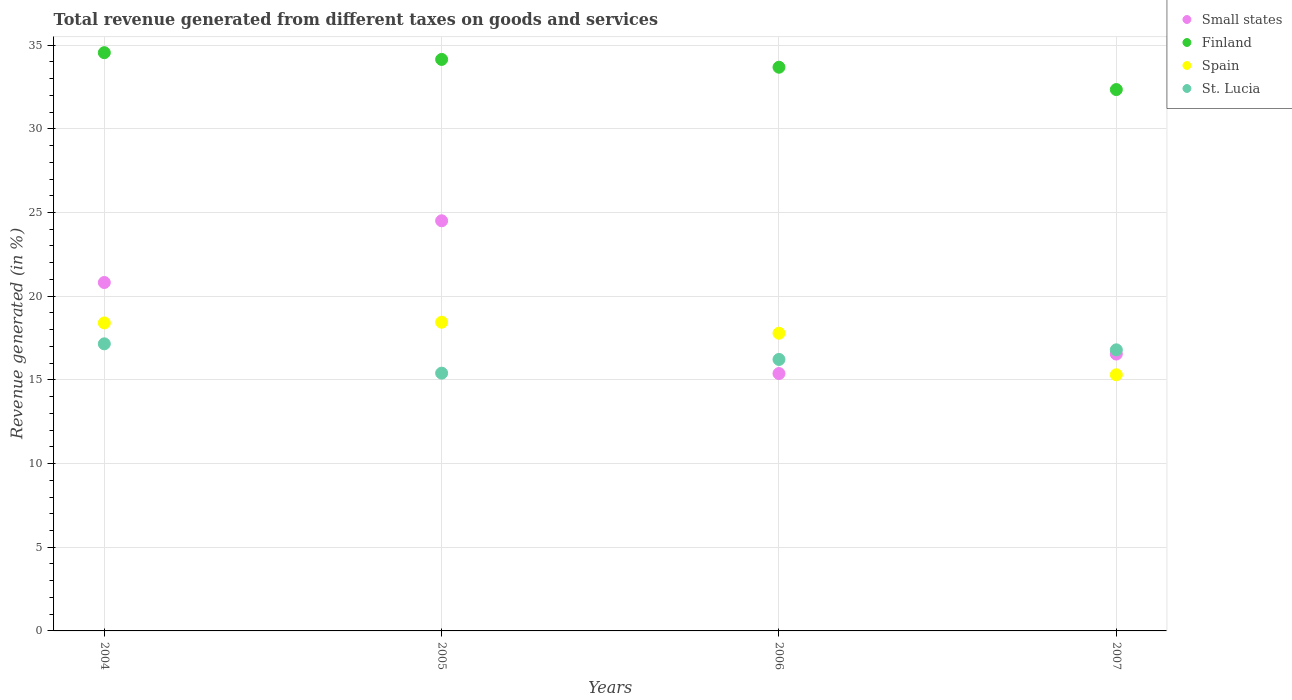What is the total revenue generated in St. Lucia in 2007?
Your answer should be compact. 16.8. Across all years, what is the maximum total revenue generated in Small states?
Provide a succinct answer. 24.51. Across all years, what is the minimum total revenue generated in St. Lucia?
Make the answer very short. 15.4. In which year was the total revenue generated in Finland maximum?
Ensure brevity in your answer.  2004. In which year was the total revenue generated in Finland minimum?
Keep it short and to the point. 2007. What is the total total revenue generated in Spain in the graph?
Provide a succinct answer. 69.94. What is the difference between the total revenue generated in Finland in 2004 and that in 2006?
Your answer should be very brief. 0.87. What is the difference between the total revenue generated in Finland in 2004 and the total revenue generated in Small states in 2005?
Offer a very short reply. 10.05. What is the average total revenue generated in Spain per year?
Provide a short and direct response. 17.49. In the year 2006, what is the difference between the total revenue generated in Finland and total revenue generated in St. Lucia?
Give a very brief answer. 17.46. In how many years, is the total revenue generated in Small states greater than 4 %?
Give a very brief answer. 4. What is the ratio of the total revenue generated in Finland in 2004 to that in 2006?
Ensure brevity in your answer.  1.03. Is the total revenue generated in St. Lucia in 2006 less than that in 2007?
Offer a very short reply. Yes. What is the difference between the highest and the second highest total revenue generated in Spain?
Offer a very short reply. 0.04. What is the difference between the highest and the lowest total revenue generated in Finland?
Your answer should be compact. 2.2. In how many years, is the total revenue generated in St. Lucia greater than the average total revenue generated in St. Lucia taken over all years?
Provide a short and direct response. 2. Is the sum of the total revenue generated in Finland in 2004 and 2006 greater than the maximum total revenue generated in St. Lucia across all years?
Your answer should be compact. Yes. Is it the case that in every year, the sum of the total revenue generated in Finland and total revenue generated in Small states  is greater than the sum of total revenue generated in St. Lucia and total revenue generated in Spain?
Offer a terse response. Yes. Is it the case that in every year, the sum of the total revenue generated in Small states and total revenue generated in Spain  is greater than the total revenue generated in St. Lucia?
Your answer should be very brief. Yes. Does the total revenue generated in St. Lucia monotonically increase over the years?
Keep it short and to the point. No. Is the total revenue generated in Spain strictly less than the total revenue generated in Small states over the years?
Provide a succinct answer. No. How many years are there in the graph?
Ensure brevity in your answer.  4. What is the difference between two consecutive major ticks on the Y-axis?
Offer a very short reply. 5. What is the title of the graph?
Make the answer very short. Total revenue generated from different taxes on goods and services. Does "Guinea" appear as one of the legend labels in the graph?
Provide a short and direct response. No. What is the label or title of the Y-axis?
Ensure brevity in your answer.  Revenue generated (in %). What is the Revenue generated (in %) in Small states in 2004?
Offer a very short reply. 20.82. What is the Revenue generated (in %) in Finland in 2004?
Provide a short and direct response. 34.55. What is the Revenue generated (in %) of Spain in 2004?
Provide a succinct answer. 18.4. What is the Revenue generated (in %) of St. Lucia in 2004?
Your answer should be very brief. 17.15. What is the Revenue generated (in %) of Small states in 2005?
Ensure brevity in your answer.  24.51. What is the Revenue generated (in %) in Finland in 2005?
Ensure brevity in your answer.  34.15. What is the Revenue generated (in %) of Spain in 2005?
Your answer should be compact. 18.45. What is the Revenue generated (in %) in St. Lucia in 2005?
Your response must be concise. 15.4. What is the Revenue generated (in %) in Small states in 2006?
Keep it short and to the point. 15.38. What is the Revenue generated (in %) in Finland in 2006?
Your response must be concise. 33.68. What is the Revenue generated (in %) in Spain in 2006?
Offer a very short reply. 17.79. What is the Revenue generated (in %) of St. Lucia in 2006?
Offer a very short reply. 16.22. What is the Revenue generated (in %) of Small states in 2007?
Provide a short and direct response. 16.54. What is the Revenue generated (in %) in Finland in 2007?
Make the answer very short. 32.35. What is the Revenue generated (in %) of Spain in 2007?
Provide a short and direct response. 15.31. What is the Revenue generated (in %) of St. Lucia in 2007?
Provide a short and direct response. 16.8. Across all years, what is the maximum Revenue generated (in %) of Small states?
Ensure brevity in your answer.  24.51. Across all years, what is the maximum Revenue generated (in %) of Finland?
Make the answer very short. 34.55. Across all years, what is the maximum Revenue generated (in %) of Spain?
Ensure brevity in your answer.  18.45. Across all years, what is the maximum Revenue generated (in %) in St. Lucia?
Your answer should be very brief. 17.15. Across all years, what is the minimum Revenue generated (in %) in Small states?
Give a very brief answer. 15.38. Across all years, what is the minimum Revenue generated (in %) in Finland?
Offer a terse response. 32.35. Across all years, what is the minimum Revenue generated (in %) of Spain?
Give a very brief answer. 15.31. Across all years, what is the minimum Revenue generated (in %) in St. Lucia?
Your answer should be compact. 15.4. What is the total Revenue generated (in %) of Small states in the graph?
Provide a short and direct response. 77.25. What is the total Revenue generated (in %) of Finland in the graph?
Ensure brevity in your answer.  134.73. What is the total Revenue generated (in %) of Spain in the graph?
Provide a succinct answer. 69.94. What is the total Revenue generated (in %) in St. Lucia in the graph?
Make the answer very short. 65.57. What is the difference between the Revenue generated (in %) in Small states in 2004 and that in 2005?
Offer a terse response. -3.69. What is the difference between the Revenue generated (in %) of Finland in 2004 and that in 2005?
Your response must be concise. 0.4. What is the difference between the Revenue generated (in %) in Spain in 2004 and that in 2005?
Ensure brevity in your answer.  -0.04. What is the difference between the Revenue generated (in %) of St. Lucia in 2004 and that in 2005?
Give a very brief answer. 1.75. What is the difference between the Revenue generated (in %) of Small states in 2004 and that in 2006?
Keep it short and to the point. 5.44. What is the difference between the Revenue generated (in %) in Finland in 2004 and that in 2006?
Your answer should be compact. 0.87. What is the difference between the Revenue generated (in %) of Spain in 2004 and that in 2006?
Provide a succinct answer. 0.62. What is the difference between the Revenue generated (in %) in St. Lucia in 2004 and that in 2006?
Your answer should be very brief. 0.93. What is the difference between the Revenue generated (in %) in Small states in 2004 and that in 2007?
Your response must be concise. 4.28. What is the difference between the Revenue generated (in %) of Finland in 2004 and that in 2007?
Provide a short and direct response. 2.2. What is the difference between the Revenue generated (in %) of Spain in 2004 and that in 2007?
Offer a very short reply. 3.1. What is the difference between the Revenue generated (in %) of St. Lucia in 2004 and that in 2007?
Your answer should be compact. 0.36. What is the difference between the Revenue generated (in %) of Small states in 2005 and that in 2006?
Provide a succinct answer. 9.13. What is the difference between the Revenue generated (in %) of Finland in 2005 and that in 2006?
Provide a succinct answer. 0.47. What is the difference between the Revenue generated (in %) of Spain in 2005 and that in 2006?
Make the answer very short. 0.66. What is the difference between the Revenue generated (in %) in St. Lucia in 2005 and that in 2006?
Make the answer very short. -0.82. What is the difference between the Revenue generated (in %) in Small states in 2005 and that in 2007?
Your answer should be very brief. 7.96. What is the difference between the Revenue generated (in %) in Finland in 2005 and that in 2007?
Give a very brief answer. 1.8. What is the difference between the Revenue generated (in %) in Spain in 2005 and that in 2007?
Make the answer very short. 3.14. What is the difference between the Revenue generated (in %) in St. Lucia in 2005 and that in 2007?
Your answer should be compact. -1.39. What is the difference between the Revenue generated (in %) in Small states in 2006 and that in 2007?
Offer a very short reply. -1.16. What is the difference between the Revenue generated (in %) of Finland in 2006 and that in 2007?
Provide a short and direct response. 1.33. What is the difference between the Revenue generated (in %) of Spain in 2006 and that in 2007?
Offer a very short reply. 2.48. What is the difference between the Revenue generated (in %) of St. Lucia in 2006 and that in 2007?
Ensure brevity in your answer.  -0.57. What is the difference between the Revenue generated (in %) in Small states in 2004 and the Revenue generated (in %) in Finland in 2005?
Give a very brief answer. -13.33. What is the difference between the Revenue generated (in %) in Small states in 2004 and the Revenue generated (in %) in Spain in 2005?
Your answer should be very brief. 2.37. What is the difference between the Revenue generated (in %) in Small states in 2004 and the Revenue generated (in %) in St. Lucia in 2005?
Ensure brevity in your answer.  5.42. What is the difference between the Revenue generated (in %) of Finland in 2004 and the Revenue generated (in %) of Spain in 2005?
Your answer should be compact. 16.1. What is the difference between the Revenue generated (in %) of Finland in 2004 and the Revenue generated (in %) of St. Lucia in 2005?
Provide a short and direct response. 19.15. What is the difference between the Revenue generated (in %) of Spain in 2004 and the Revenue generated (in %) of St. Lucia in 2005?
Give a very brief answer. 3. What is the difference between the Revenue generated (in %) in Small states in 2004 and the Revenue generated (in %) in Finland in 2006?
Your answer should be very brief. -12.86. What is the difference between the Revenue generated (in %) in Small states in 2004 and the Revenue generated (in %) in Spain in 2006?
Offer a terse response. 3.03. What is the difference between the Revenue generated (in %) of Small states in 2004 and the Revenue generated (in %) of St. Lucia in 2006?
Keep it short and to the point. 4.6. What is the difference between the Revenue generated (in %) in Finland in 2004 and the Revenue generated (in %) in Spain in 2006?
Provide a succinct answer. 16.76. What is the difference between the Revenue generated (in %) of Finland in 2004 and the Revenue generated (in %) of St. Lucia in 2006?
Give a very brief answer. 18.33. What is the difference between the Revenue generated (in %) in Spain in 2004 and the Revenue generated (in %) in St. Lucia in 2006?
Keep it short and to the point. 2.18. What is the difference between the Revenue generated (in %) of Small states in 2004 and the Revenue generated (in %) of Finland in 2007?
Keep it short and to the point. -11.53. What is the difference between the Revenue generated (in %) in Small states in 2004 and the Revenue generated (in %) in Spain in 2007?
Give a very brief answer. 5.51. What is the difference between the Revenue generated (in %) in Small states in 2004 and the Revenue generated (in %) in St. Lucia in 2007?
Keep it short and to the point. 4.02. What is the difference between the Revenue generated (in %) in Finland in 2004 and the Revenue generated (in %) in Spain in 2007?
Offer a terse response. 19.24. What is the difference between the Revenue generated (in %) in Finland in 2004 and the Revenue generated (in %) in St. Lucia in 2007?
Make the answer very short. 17.76. What is the difference between the Revenue generated (in %) in Spain in 2004 and the Revenue generated (in %) in St. Lucia in 2007?
Your answer should be compact. 1.61. What is the difference between the Revenue generated (in %) of Small states in 2005 and the Revenue generated (in %) of Finland in 2006?
Give a very brief answer. -9.18. What is the difference between the Revenue generated (in %) in Small states in 2005 and the Revenue generated (in %) in Spain in 2006?
Provide a short and direct response. 6.72. What is the difference between the Revenue generated (in %) in Small states in 2005 and the Revenue generated (in %) in St. Lucia in 2006?
Offer a very short reply. 8.28. What is the difference between the Revenue generated (in %) in Finland in 2005 and the Revenue generated (in %) in Spain in 2006?
Provide a short and direct response. 16.36. What is the difference between the Revenue generated (in %) in Finland in 2005 and the Revenue generated (in %) in St. Lucia in 2006?
Keep it short and to the point. 17.93. What is the difference between the Revenue generated (in %) of Spain in 2005 and the Revenue generated (in %) of St. Lucia in 2006?
Provide a short and direct response. 2.23. What is the difference between the Revenue generated (in %) of Small states in 2005 and the Revenue generated (in %) of Finland in 2007?
Give a very brief answer. -7.84. What is the difference between the Revenue generated (in %) in Small states in 2005 and the Revenue generated (in %) in Spain in 2007?
Make the answer very short. 9.2. What is the difference between the Revenue generated (in %) of Small states in 2005 and the Revenue generated (in %) of St. Lucia in 2007?
Provide a short and direct response. 7.71. What is the difference between the Revenue generated (in %) in Finland in 2005 and the Revenue generated (in %) in Spain in 2007?
Make the answer very short. 18.84. What is the difference between the Revenue generated (in %) of Finland in 2005 and the Revenue generated (in %) of St. Lucia in 2007?
Make the answer very short. 17.35. What is the difference between the Revenue generated (in %) of Spain in 2005 and the Revenue generated (in %) of St. Lucia in 2007?
Provide a succinct answer. 1.65. What is the difference between the Revenue generated (in %) of Small states in 2006 and the Revenue generated (in %) of Finland in 2007?
Your answer should be compact. -16.97. What is the difference between the Revenue generated (in %) in Small states in 2006 and the Revenue generated (in %) in Spain in 2007?
Make the answer very short. 0.07. What is the difference between the Revenue generated (in %) in Small states in 2006 and the Revenue generated (in %) in St. Lucia in 2007?
Make the answer very short. -1.42. What is the difference between the Revenue generated (in %) of Finland in 2006 and the Revenue generated (in %) of Spain in 2007?
Your answer should be very brief. 18.37. What is the difference between the Revenue generated (in %) in Finland in 2006 and the Revenue generated (in %) in St. Lucia in 2007?
Keep it short and to the point. 16.89. What is the difference between the Revenue generated (in %) of Spain in 2006 and the Revenue generated (in %) of St. Lucia in 2007?
Your answer should be compact. 0.99. What is the average Revenue generated (in %) of Small states per year?
Offer a very short reply. 19.31. What is the average Revenue generated (in %) in Finland per year?
Your answer should be compact. 33.68. What is the average Revenue generated (in %) of Spain per year?
Your answer should be very brief. 17.49. What is the average Revenue generated (in %) of St. Lucia per year?
Provide a short and direct response. 16.39. In the year 2004, what is the difference between the Revenue generated (in %) of Small states and Revenue generated (in %) of Finland?
Ensure brevity in your answer.  -13.73. In the year 2004, what is the difference between the Revenue generated (in %) of Small states and Revenue generated (in %) of Spain?
Your answer should be compact. 2.42. In the year 2004, what is the difference between the Revenue generated (in %) in Small states and Revenue generated (in %) in St. Lucia?
Keep it short and to the point. 3.66. In the year 2004, what is the difference between the Revenue generated (in %) of Finland and Revenue generated (in %) of Spain?
Provide a short and direct response. 16.15. In the year 2004, what is the difference between the Revenue generated (in %) of Finland and Revenue generated (in %) of St. Lucia?
Ensure brevity in your answer.  17.4. In the year 2004, what is the difference between the Revenue generated (in %) in Spain and Revenue generated (in %) in St. Lucia?
Your answer should be very brief. 1.25. In the year 2005, what is the difference between the Revenue generated (in %) of Small states and Revenue generated (in %) of Finland?
Make the answer very short. -9.64. In the year 2005, what is the difference between the Revenue generated (in %) in Small states and Revenue generated (in %) in Spain?
Your answer should be compact. 6.06. In the year 2005, what is the difference between the Revenue generated (in %) of Small states and Revenue generated (in %) of St. Lucia?
Your answer should be compact. 9.1. In the year 2005, what is the difference between the Revenue generated (in %) in Finland and Revenue generated (in %) in Spain?
Make the answer very short. 15.7. In the year 2005, what is the difference between the Revenue generated (in %) of Finland and Revenue generated (in %) of St. Lucia?
Provide a succinct answer. 18.75. In the year 2005, what is the difference between the Revenue generated (in %) of Spain and Revenue generated (in %) of St. Lucia?
Provide a short and direct response. 3.04. In the year 2006, what is the difference between the Revenue generated (in %) in Small states and Revenue generated (in %) in Finland?
Offer a terse response. -18.3. In the year 2006, what is the difference between the Revenue generated (in %) in Small states and Revenue generated (in %) in Spain?
Provide a succinct answer. -2.41. In the year 2006, what is the difference between the Revenue generated (in %) in Small states and Revenue generated (in %) in St. Lucia?
Ensure brevity in your answer.  -0.84. In the year 2006, what is the difference between the Revenue generated (in %) in Finland and Revenue generated (in %) in Spain?
Provide a short and direct response. 15.89. In the year 2006, what is the difference between the Revenue generated (in %) in Finland and Revenue generated (in %) in St. Lucia?
Ensure brevity in your answer.  17.46. In the year 2006, what is the difference between the Revenue generated (in %) of Spain and Revenue generated (in %) of St. Lucia?
Keep it short and to the point. 1.57. In the year 2007, what is the difference between the Revenue generated (in %) in Small states and Revenue generated (in %) in Finland?
Provide a short and direct response. -15.8. In the year 2007, what is the difference between the Revenue generated (in %) of Small states and Revenue generated (in %) of Spain?
Give a very brief answer. 1.24. In the year 2007, what is the difference between the Revenue generated (in %) in Small states and Revenue generated (in %) in St. Lucia?
Ensure brevity in your answer.  -0.25. In the year 2007, what is the difference between the Revenue generated (in %) in Finland and Revenue generated (in %) in Spain?
Make the answer very short. 17.04. In the year 2007, what is the difference between the Revenue generated (in %) of Finland and Revenue generated (in %) of St. Lucia?
Offer a terse response. 15.55. In the year 2007, what is the difference between the Revenue generated (in %) of Spain and Revenue generated (in %) of St. Lucia?
Offer a very short reply. -1.49. What is the ratio of the Revenue generated (in %) in Small states in 2004 to that in 2005?
Make the answer very short. 0.85. What is the ratio of the Revenue generated (in %) of Finland in 2004 to that in 2005?
Keep it short and to the point. 1.01. What is the ratio of the Revenue generated (in %) of Spain in 2004 to that in 2005?
Provide a succinct answer. 1. What is the ratio of the Revenue generated (in %) of St. Lucia in 2004 to that in 2005?
Ensure brevity in your answer.  1.11. What is the ratio of the Revenue generated (in %) in Small states in 2004 to that in 2006?
Provide a succinct answer. 1.35. What is the ratio of the Revenue generated (in %) of Finland in 2004 to that in 2006?
Provide a succinct answer. 1.03. What is the ratio of the Revenue generated (in %) of Spain in 2004 to that in 2006?
Make the answer very short. 1.03. What is the ratio of the Revenue generated (in %) in St. Lucia in 2004 to that in 2006?
Give a very brief answer. 1.06. What is the ratio of the Revenue generated (in %) of Small states in 2004 to that in 2007?
Offer a terse response. 1.26. What is the ratio of the Revenue generated (in %) of Finland in 2004 to that in 2007?
Keep it short and to the point. 1.07. What is the ratio of the Revenue generated (in %) in Spain in 2004 to that in 2007?
Your response must be concise. 1.2. What is the ratio of the Revenue generated (in %) of St. Lucia in 2004 to that in 2007?
Keep it short and to the point. 1.02. What is the ratio of the Revenue generated (in %) of Small states in 2005 to that in 2006?
Offer a terse response. 1.59. What is the ratio of the Revenue generated (in %) in Finland in 2005 to that in 2006?
Ensure brevity in your answer.  1.01. What is the ratio of the Revenue generated (in %) in Spain in 2005 to that in 2006?
Keep it short and to the point. 1.04. What is the ratio of the Revenue generated (in %) of St. Lucia in 2005 to that in 2006?
Provide a short and direct response. 0.95. What is the ratio of the Revenue generated (in %) of Small states in 2005 to that in 2007?
Offer a terse response. 1.48. What is the ratio of the Revenue generated (in %) in Finland in 2005 to that in 2007?
Offer a very short reply. 1.06. What is the ratio of the Revenue generated (in %) in Spain in 2005 to that in 2007?
Your response must be concise. 1.21. What is the ratio of the Revenue generated (in %) of St. Lucia in 2005 to that in 2007?
Give a very brief answer. 0.92. What is the ratio of the Revenue generated (in %) in Small states in 2006 to that in 2007?
Give a very brief answer. 0.93. What is the ratio of the Revenue generated (in %) in Finland in 2006 to that in 2007?
Your response must be concise. 1.04. What is the ratio of the Revenue generated (in %) in Spain in 2006 to that in 2007?
Ensure brevity in your answer.  1.16. What is the ratio of the Revenue generated (in %) of St. Lucia in 2006 to that in 2007?
Your response must be concise. 0.97. What is the difference between the highest and the second highest Revenue generated (in %) of Small states?
Offer a terse response. 3.69. What is the difference between the highest and the second highest Revenue generated (in %) of Finland?
Your answer should be compact. 0.4. What is the difference between the highest and the second highest Revenue generated (in %) of Spain?
Provide a succinct answer. 0.04. What is the difference between the highest and the second highest Revenue generated (in %) of St. Lucia?
Offer a very short reply. 0.36. What is the difference between the highest and the lowest Revenue generated (in %) in Small states?
Ensure brevity in your answer.  9.13. What is the difference between the highest and the lowest Revenue generated (in %) in Finland?
Provide a short and direct response. 2.2. What is the difference between the highest and the lowest Revenue generated (in %) in Spain?
Provide a short and direct response. 3.14. What is the difference between the highest and the lowest Revenue generated (in %) of St. Lucia?
Ensure brevity in your answer.  1.75. 